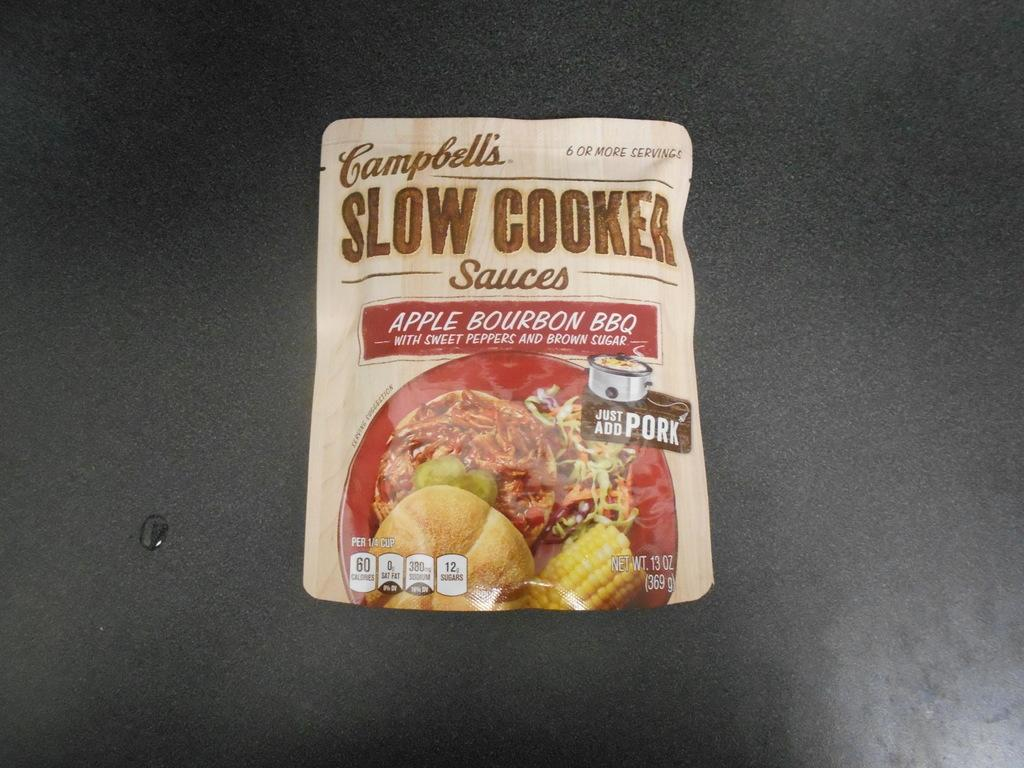What is the main object in the center of the image? There is a packet in the center of the image. What is the color of the surface on which the packet is placed? The packet is on a black surface. What can be seen on the left side of the image? There is water on the left side of the image. What type of riddle is the achiever solving in the image? There is no achiever or riddle present in the image; it only features a packet on a black surface and water on the left side. 